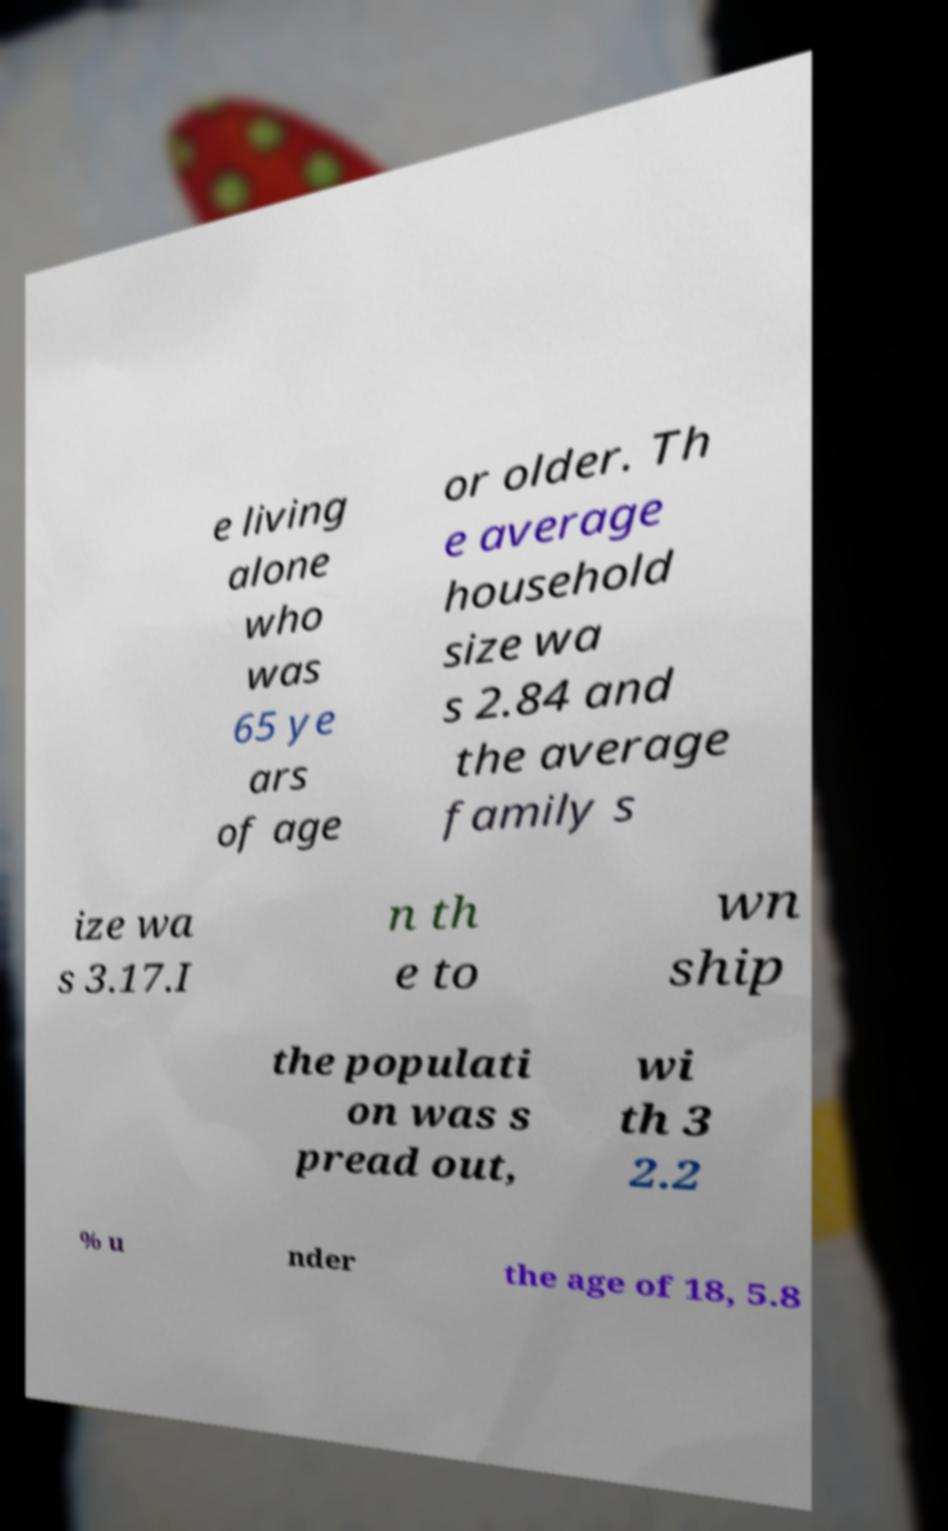There's text embedded in this image that I need extracted. Can you transcribe it verbatim? e living alone who was 65 ye ars of age or older. Th e average household size wa s 2.84 and the average family s ize wa s 3.17.I n th e to wn ship the populati on was s pread out, wi th 3 2.2 % u nder the age of 18, 5.8 